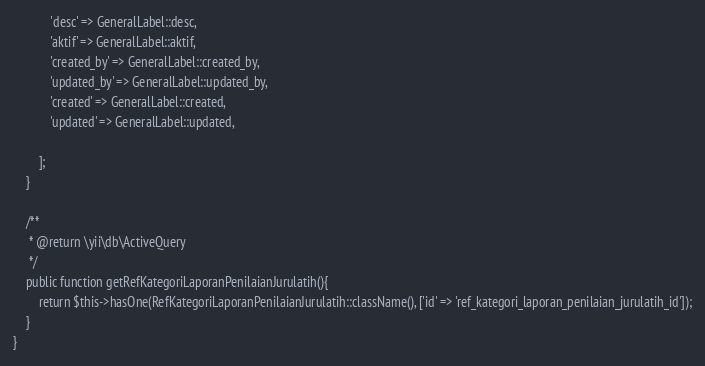<code> <loc_0><loc_0><loc_500><loc_500><_PHP_>            'desc' => GeneralLabel::desc,
            'aktif' => GeneralLabel::aktif,
            'created_by' => GeneralLabel::created_by,
            'updated_by' => GeneralLabel::updated_by,
            'created' => GeneralLabel::created,
            'updated' => GeneralLabel::updated,

        ];
    }
	
	/**
     * @return \yii\db\ActiveQuery
     */
    public function getRefKategoriLaporanPenilaianJurulatih(){
        return $this->hasOne(RefKategoriLaporanPenilaianJurulatih::className(), ['id' => 'ref_kategori_laporan_penilaian_jurulatih_id']);
    }
}
</code> 